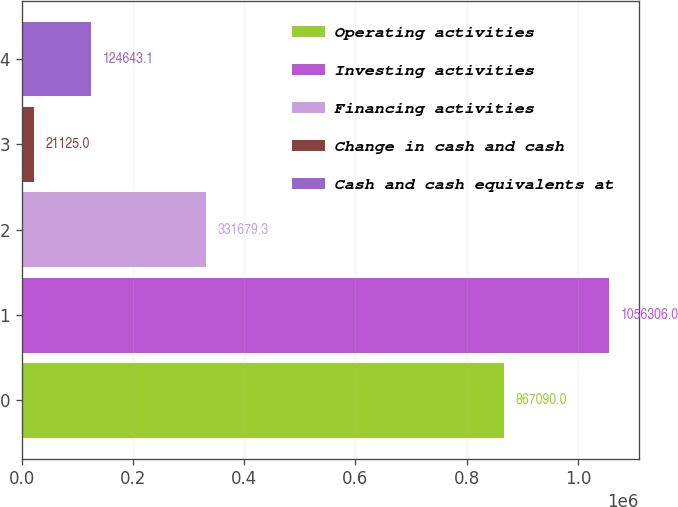Convert chart. <chart><loc_0><loc_0><loc_500><loc_500><bar_chart><fcel>Operating activities<fcel>Investing activities<fcel>Financing activities<fcel>Change in cash and cash<fcel>Cash and cash equivalents at<nl><fcel>867090<fcel>1.05631e+06<fcel>331679<fcel>21125<fcel>124643<nl></chart> 